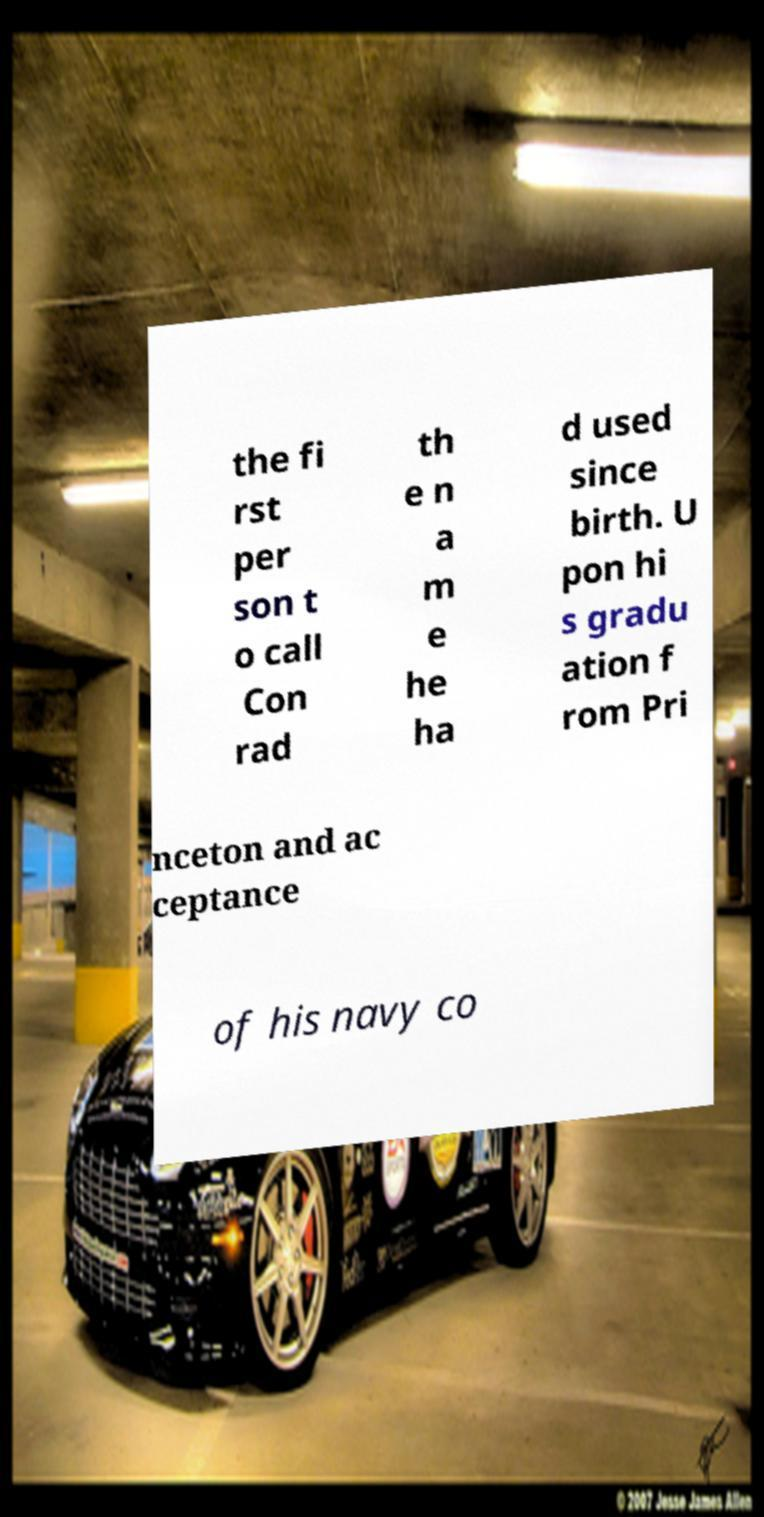Could you extract and type out the text from this image? the fi rst per son t o call Con rad th e n a m e he ha d used since birth. U pon hi s gradu ation f rom Pri nceton and ac ceptance of his navy co 